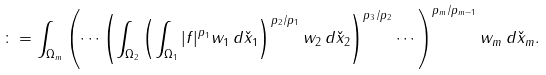Convert formula to latex. <formula><loc_0><loc_0><loc_500><loc_500>\colon = \int _ { \Omega _ { m } } \left ( \cdots \left ( \int _ { \Omega _ { 2 } } \left ( \int _ { \Omega _ { 1 } } | f | ^ { p _ { 1 } } w _ { 1 } \, d \check { x } _ { 1 } \right ) ^ { p _ { 2 } / p _ { 1 } } w _ { 2 } \, d \check { x } _ { 2 } \right ) ^ { p _ { 3 } / p _ { 2 } } \cdots \right ) ^ { p _ { m } / p _ { m - 1 } } w _ { m } \, d \check { x } _ { m } .</formula> 